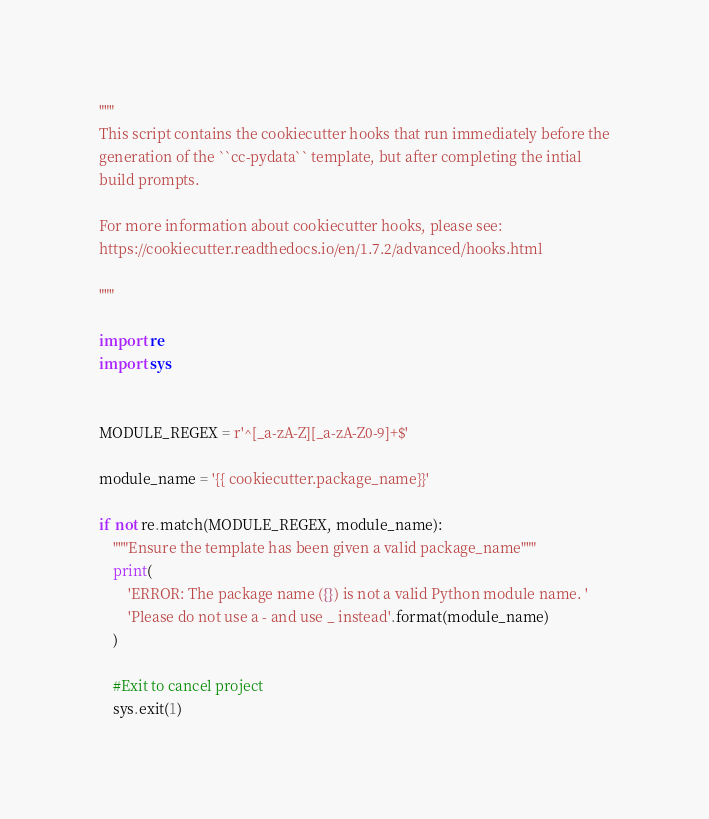<code> <loc_0><loc_0><loc_500><loc_500><_Python_>"""
This script contains the cookiecutter hooks that run immediately before the
generation of the ``cc-pydata`` template, but after completing the intial
build prompts.

For more information about cookiecutter hooks, please see:
https://cookiecutter.readthedocs.io/en/1.7.2/advanced/hooks.html

"""

import re
import sys


MODULE_REGEX = r'^[_a-zA-Z][_a-zA-Z0-9]+$'

module_name = '{{ cookiecutter.package_name}}'

if not re.match(MODULE_REGEX, module_name):
    """Ensure the template has been given a valid package_name"""
    print(
        'ERROR: The package name ({}) is not a valid Python module name. '
        'Please do not use a - and use _ instead'.format(module_name)
    )

    #Exit to cancel project
    sys.exit(1)
</code> 